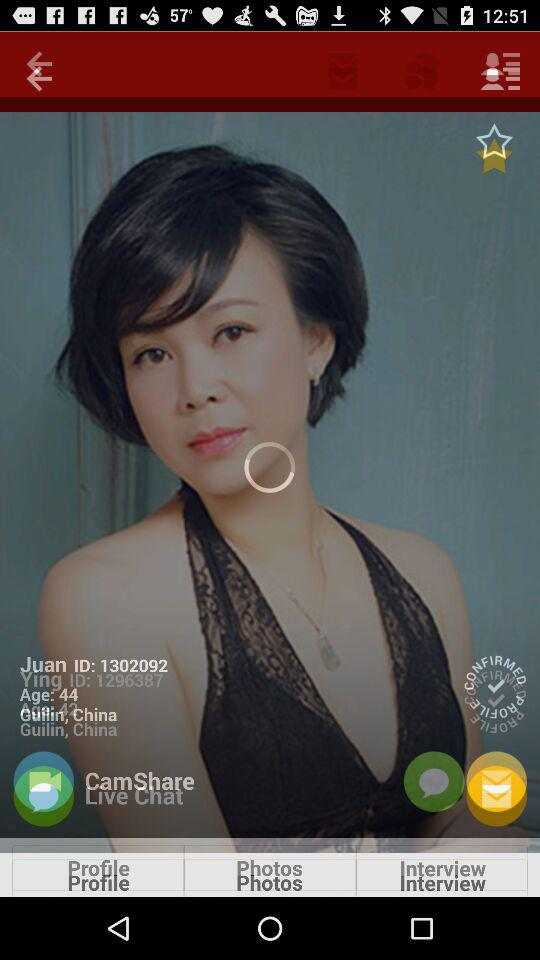What is the age of Ying? The age of Ying is 42 years. 